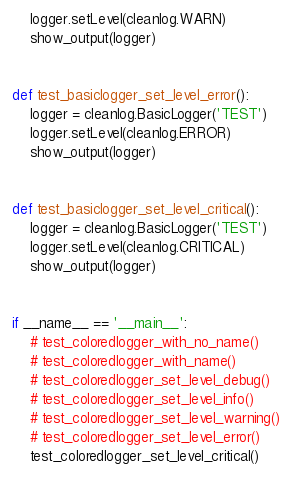Convert code to text. <code><loc_0><loc_0><loc_500><loc_500><_Python_>    logger.setLevel(cleanlog.WARN)
    show_output(logger)


def test_basiclogger_set_level_error():
    logger = cleanlog.BasicLogger('TEST')
    logger.setLevel(cleanlog.ERROR)
    show_output(logger)


def test_basiclogger_set_level_critical():
    logger = cleanlog.BasicLogger('TEST')
    logger.setLevel(cleanlog.CRITICAL)
    show_output(logger)


if __name__ == '__main__':
    # test_coloredlogger_with_no_name()
    # test_coloredlogger_with_name()
    # test_coloredlogger_set_level_debug()
    # test_coloredlogger_set_level_info()
    # test_coloredlogger_set_level_warning()
    # test_coloredlogger_set_level_error()
    test_coloredlogger_set_level_critical()
</code> 